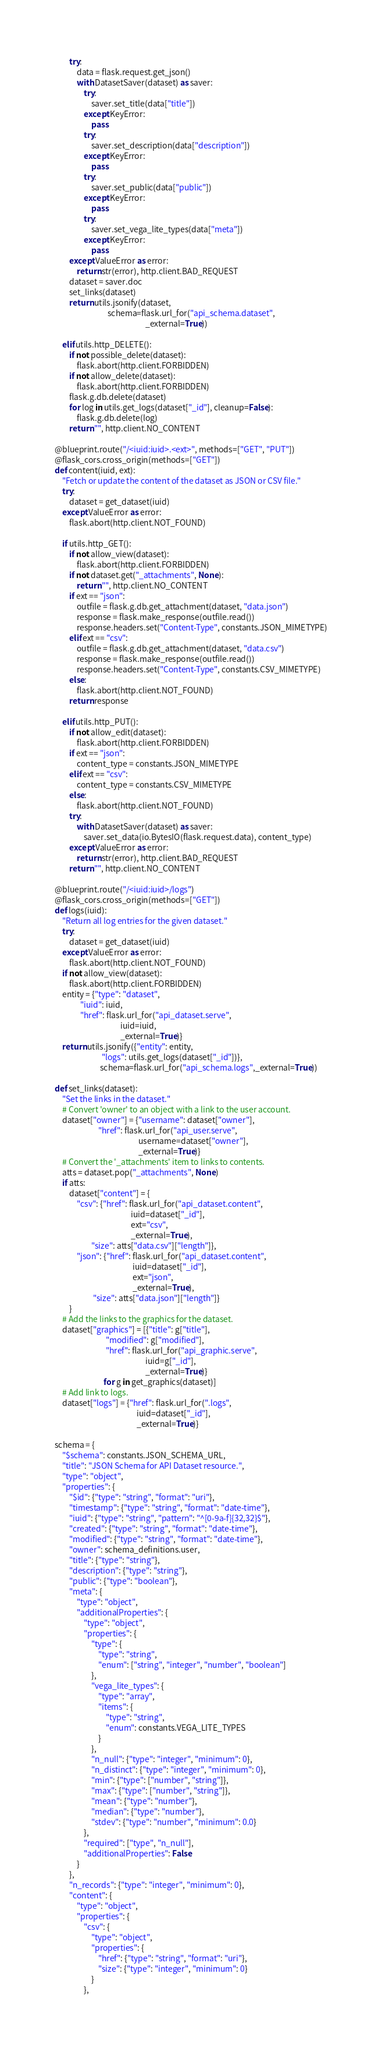<code> <loc_0><loc_0><loc_500><loc_500><_Python_>        try:
            data = flask.request.get_json()
            with DatasetSaver(dataset) as saver:
                try:
                    saver.set_title(data["title"])
                except KeyError:
                    pass
                try:
                    saver.set_description(data["description"])
                except KeyError:
                    pass
                try:
                    saver.set_public(data["public"])
                except KeyError:
                    pass
                try:
                    saver.set_vega_lite_types(data["meta"])
                except KeyError:
                    pass
        except ValueError as error:
            return str(error), http.client.BAD_REQUEST
        dataset = saver.doc
        set_links(dataset)
        return utils.jsonify(dataset,
                             schema=flask.url_for("api_schema.dataset",
                                                  _external=True))

    elif utils.http_DELETE():
        if not possible_delete(dataset):
            flask.abort(http.client.FORBIDDEN)
        if not allow_delete(dataset):
            flask.abort(http.client.FORBIDDEN)
        flask.g.db.delete(dataset)
        for log in utils.get_logs(dataset["_id"], cleanup=False):
            flask.g.db.delete(log)
        return "", http.client.NO_CONTENT

@blueprint.route("/<iuid:iuid>.<ext>", methods=["GET", "PUT"])
@flask_cors.cross_origin(methods=["GET"])
def content(iuid, ext):
    "Fetch or update the content of the dataset as JSON or CSV file."
    try:
        dataset = get_dataset(iuid)
    except ValueError as error:
        flask.abort(http.client.NOT_FOUND)

    if utils.http_GET():
        if not allow_view(dataset):
            flask.abort(http.client.FORBIDDEN)
        if not dataset.get("_attachments", None):
            return "", http.client.NO_CONTENT
        if ext == "json":
            outfile = flask.g.db.get_attachment(dataset, "data.json")
            response = flask.make_response(outfile.read())
            response.headers.set("Content-Type", constants.JSON_MIMETYPE)
        elif ext == "csv":
            outfile = flask.g.db.get_attachment(dataset, "data.csv")
            response = flask.make_response(outfile.read())
            response.headers.set("Content-Type", constants.CSV_MIMETYPE)
        else:
            flask.abort(http.client.NOT_FOUND)
        return response

    elif utils.http_PUT():
        if not allow_edit(dataset):
            flask.abort(http.client.FORBIDDEN)
        if ext == "json":
            content_type = constants.JSON_MIMETYPE
        elif ext == "csv":
            content_type = constants.CSV_MIMETYPE
        else:
            flask.abort(http.client.NOT_FOUND)
        try:
            with DatasetSaver(dataset) as saver:
                saver.set_data(io.BytesIO(flask.request.data), content_type)
        except ValueError as error:
            return str(error), http.client.BAD_REQUEST
        return "", http.client.NO_CONTENT

@blueprint.route("/<iuid:iuid>/logs")
@flask_cors.cross_origin(methods=["GET"])
def logs(iuid):
    "Return all log entries for the given dataset."
    try:
        dataset = get_dataset(iuid)
    except ValueError as error:
        flask.abort(http.client.NOT_FOUND)
    if not allow_view(dataset):
        flask.abort(http.client.FORBIDDEN)
    entity = {"type": "dataset",
              "iuid": iuid,
              "href": flask.url_for("api_dataset.serve",
                                    iuid=iuid,
                                    _external=True)}
    return utils.jsonify({"entity": entity,
                          "logs": utils.get_logs(dataset["_id"])},
                         schema=flask.url_for("api_schema.logs",_external=True))

def set_links(dataset):
    "Set the links in the dataset."
    # Convert 'owner' to an object with a link to the user account.
    dataset["owner"] = {"username": dataset["owner"],
                        "href": flask.url_for("api_user.serve",
                                              username=dataset["owner"],
                                              _external=True)}
    # Convert the '_attachments' item to links to contents.
    atts = dataset.pop("_attachments", None)
    if atts:
        dataset["content"] = {
            "csv": {"href": flask.url_for("api_dataset.content",
                                          iuid=dataset["_id"],
                                          ext="csv",
                                          _external=True),
                    "size": atts["data.csv"]["length"]},
            "json": {"href": flask.url_for("api_dataset.content",
                                           iuid=dataset["_id"],
                                           ext="json",
                                           _external=True),
                     "size": atts["data.json"]["length"]}
        }
    # Add the links to the graphics for the dataset.
    dataset["graphics"] = [{"title": g["title"],
                            "modified": g["modified"],
                            "href": flask.url_for("api_graphic.serve",
                                                  iuid=g["_id"],
                                                  _external=True)}
                           for g in get_graphics(dataset)]
    # Add link to logs.
    dataset["logs"] = {"href": flask.url_for(".logs", 
                                             iuid=dataset["_id"],
                                             _external=True)}

schema = {
    "$schema": constants.JSON_SCHEMA_URL,
    "title": "JSON Schema for API Dataset resource.",
    "type": "object",
    "properties": {
        "$id": {"type": "string", "format": "uri"},
        "timestamp": {"type": "string", "format": "date-time"},
        "iuid": {"type": "string", "pattern": "^[0-9a-f]{32,32}$"},
        "created": {"type": "string", "format": "date-time"},
        "modified": {"type": "string", "format": "date-time"},
        "owner": schema_definitions.user,
        "title": {"type": "string"},
        "description": {"type": "string"},
        "public": {"type": "boolean"},
        "meta": {
            "type": "object",
            "additionalProperties": {
                "type": "object",
                "properties": {
                    "type": {
                        "type": "string",
                        "enum": ["string", "integer", "number", "boolean"]
                    },
                    "vega_lite_types": {
                        "type": "array",
                        "items": {
                            "type": "string",
                            "enum": constants.VEGA_LITE_TYPES
                        }
                    },
                    "n_null": {"type": "integer", "minimum": 0},
                    "n_distinct": {"type": "integer", "minimum": 0},
                    "min": {"type": ["number", "string"]},
                    "max": {"type": ["number", "string"]},
                    "mean": {"type": "number"},
                    "median": {"type": "number"},
                    "stdev": {"type": "number", "minimum": 0.0}
                },
                "required": ["type", "n_null"],
                "additionalProperties": False
            }
        },
        "n_records": {"type": "integer", "minimum": 0},
        "content": {
            "type": "object",
            "properties": {
                "csv": {
                    "type": "object",
                    "properties": {
                        "href": {"type": "string", "format": "uri"},
                        "size": {"type": "integer", "minimum": 0}
                    }
                },</code> 